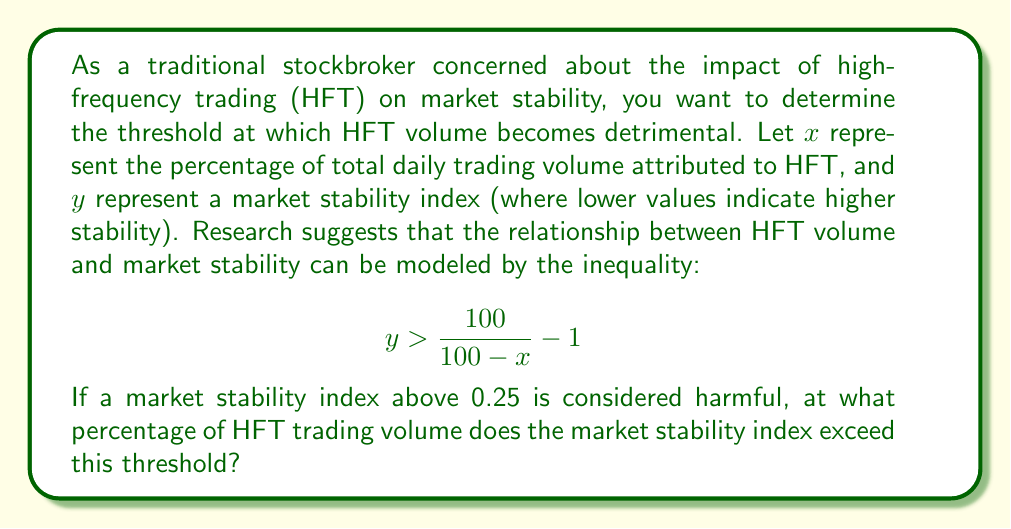Can you answer this question? To solve this problem, we need to find the value of $x$ that causes $y$ to exceed 0.25. We can do this by substituting 0.25 for $y$ in the inequality and solving for $x$.

1. Start with the given inequality:
   $$y > \frac{100}{100-x} - 1$$

2. Substitute 0.25 for $y$:
   $$0.25 > \frac{100}{100-x} - 1$$

3. Add 1 to both sides:
   $$1.25 > \frac{100}{100-x}$$

4. Take the reciprocal of both sides (flipping the inequality sign):
   $$\frac{100-x}{100} > \frac{1}{1.25}$$

5. Multiply both sides by 100:
   $$100-x > \frac{100}{1.25} = 80$$

6. Subtract 100 from both sides:
   $$-x > -20$$

7. Multiply both sides by -1 (flipping the inequality sign again):
   $$x < 20$$

Therefore, the market stability index exceeds the harmful threshold of 0.25 when the percentage of HFT volume is greater than 20%.
Answer: The threshold at which HFT volume negatively impacts market stability is 20% of total daily trading volume. 